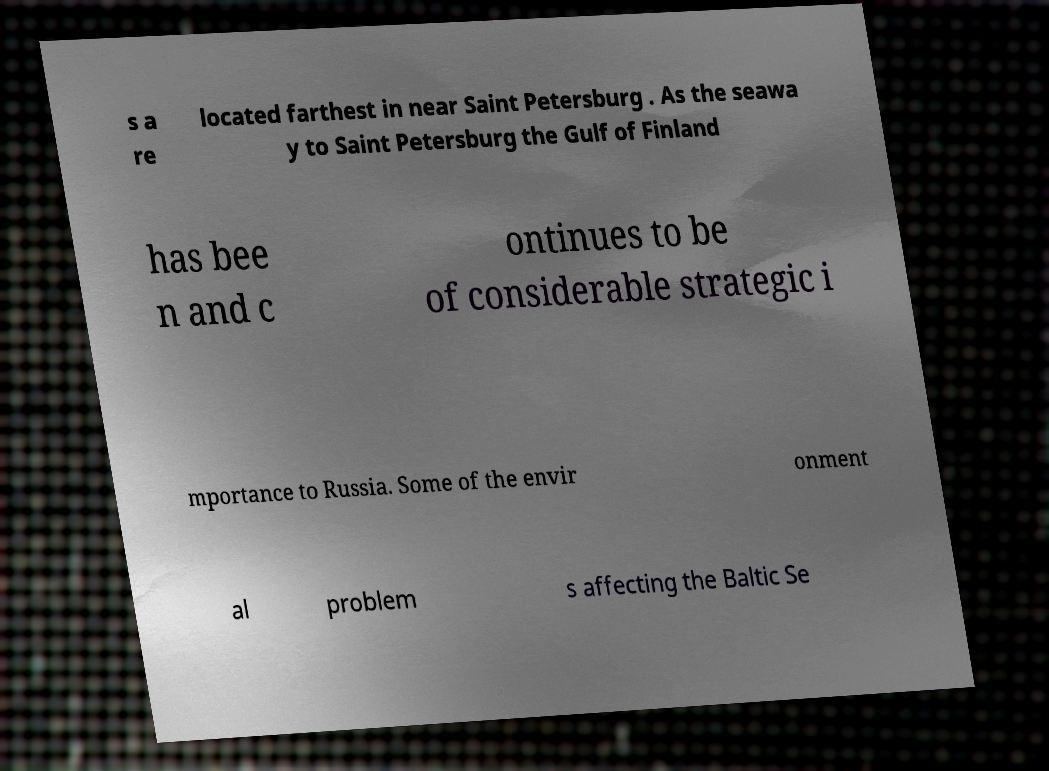Can you read and provide the text displayed in the image?This photo seems to have some interesting text. Can you extract and type it out for me? s a re located farthest in near Saint Petersburg . As the seawa y to Saint Petersburg the Gulf of Finland has bee n and c ontinues to be of considerable strategic i mportance to Russia. Some of the envir onment al problem s affecting the Baltic Se 